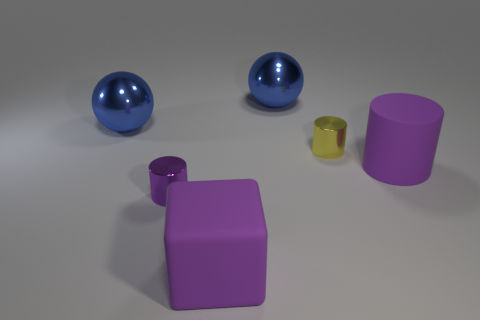There is another tiny thing that is the same shape as the tiny yellow object; what material is it?
Offer a very short reply. Metal. Is the shape of the small yellow metal thing the same as the purple shiny thing?
Your answer should be very brief. Yes. There is a big matte cube; how many yellow metallic cylinders are to the left of it?
Provide a succinct answer. 0. What is the shape of the tiny thing that is in front of the large purple matte object that is behind the purple rubber cube?
Provide a short and direct response. Cylinder. There is another tiny thing that is the same material as the small yellow thing; what is its shape?
Make the answer very short. Cylinder. Is the size of the shiny thing in front of the big matte cylinder the same as the thing that is in front of the small purple metal thing?
Give a very brief answer. No. What shape is the large blue thing that is left of the rubber cube?
Offer a terse response. Sphere. The cube has what color?
Make the answer very short. Purple. There is a purple matte cylinder; is its size the same as the rubber thing that is to the left of the big purple matte cylinder?
Your answer should be compact. Yes. What number of matte objects are either purple objects or big blue spheres?
Your response must be concise. 2. 